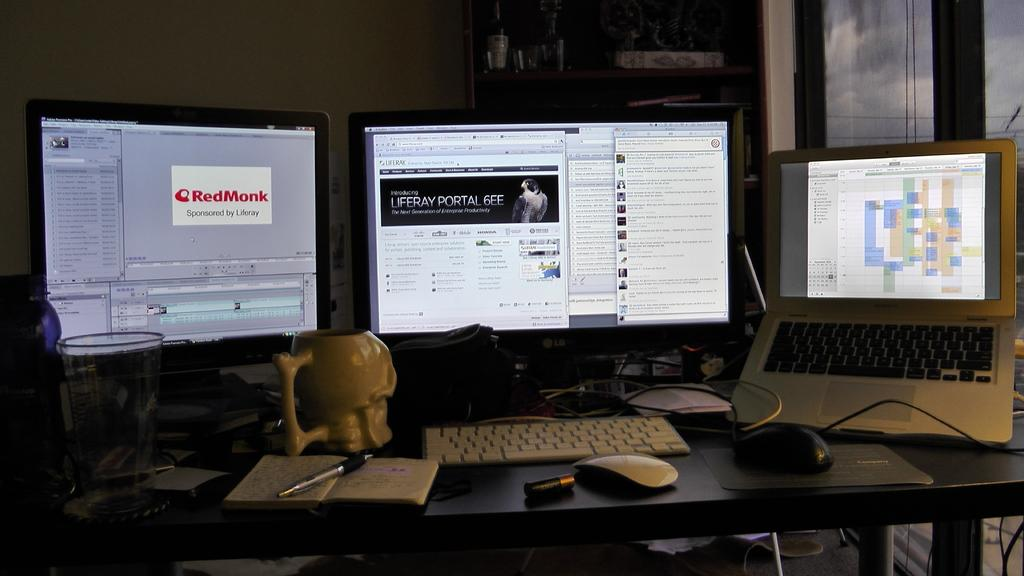<image>
Provide a brief description of the given image. A desk with 2 monitors one opening up a RedMonk webpage and a laptop. 